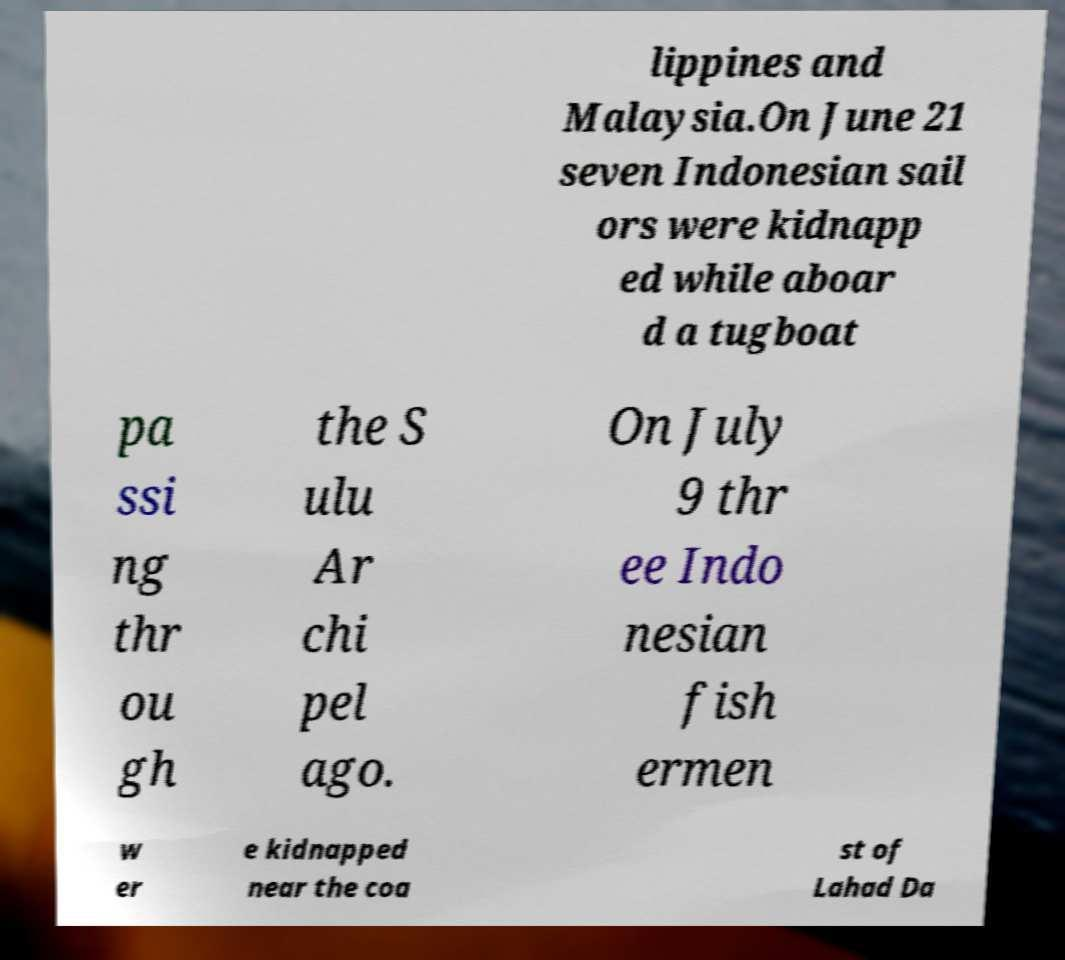Please read and relay the text visible in this image. What does it say? lippines and Malaysia.On June 21 seven Indonesian sail ors were kidnapp ed while aboar d a tugboat pa ssi ng thr ou gh the S ulu Ar chi pel ago. On July 9 thr ee Indo nesian fish ermen w er e kidnapped near the coa st of Lahad Da 